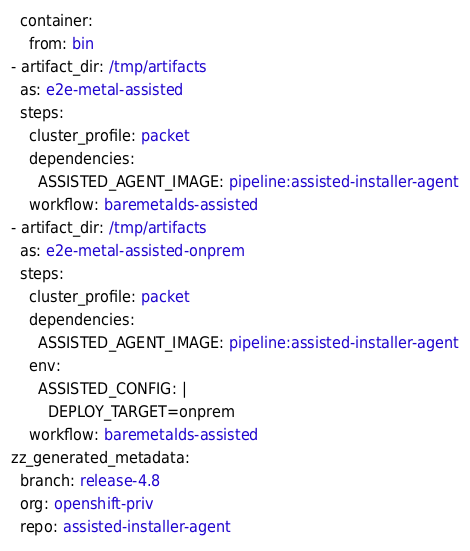<code> <loc_0><loc_0><loc_500><loc_500><_YAML_>  container:
    from: bin
- artifact_dir: /tmp/artifacts
  as: e2e-metal-assisted
  steps:
    cluster_profile: packet
    dependencies:
      ASSISTED_AGENT_IMAGE: pipeline:assisted-installer-agent
    workflow: baremetalds-assisted
- artifact_dir: /tmp/artifacts
  as: e2e-metal-assisted-onprem
  steps:
    cluster_profile: packet
    dependencies:
      ASSISTED_AGENT_IMAGE: pipeline:assisted-installer-agent
    env:
      ASSISTED_CONFIG: |
        DEPLOY_TARGET=onprem
    workflow: baremetalds-assisted
zz_generated_metadata:
  branch: release-4.8
  org: openshift-priv
  repo: assisted-installer-agent
</code> 